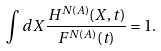Convert formula to latex. <formula><loc_0><loc_0><loc_500><loc_500>\int d X \frac { H ^ { N ( A ) } ( X , t ) } { F ^ { N ( A ) } ( t ) } = 1 .</formula> 